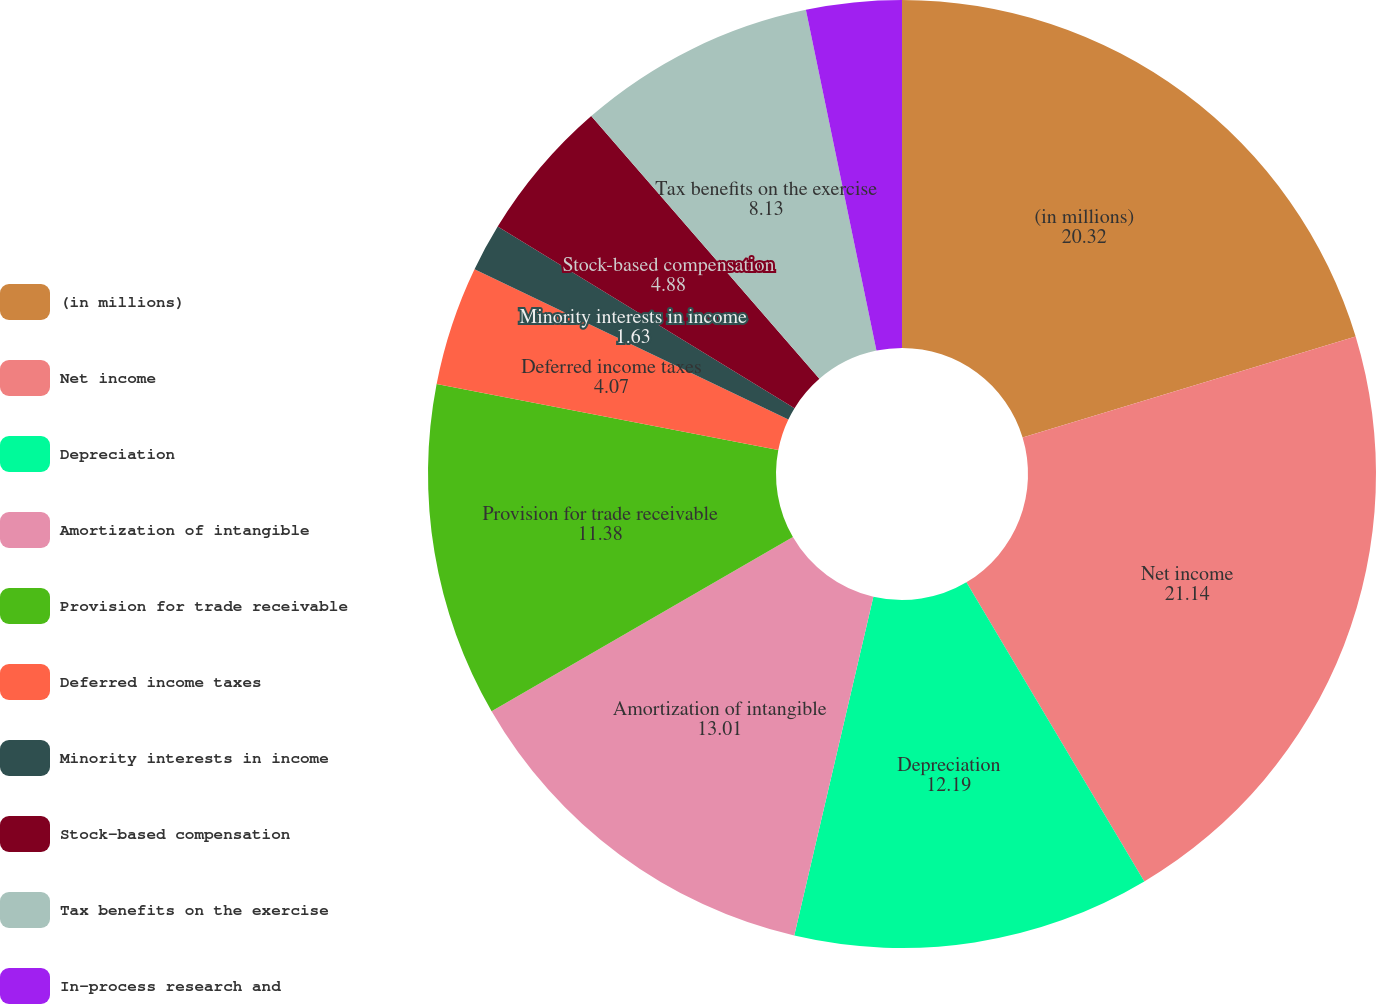Convert chart to OTSL. <chart><loc_0><loc_0><loc_500><loc_500><pie_chart><fcel>(in millions)<fcel>Net income<fcel>Depreciation<fcel>Amortization of intangible<fcel>Provision for trade receivable<fcel>Deferred income taxes<fcel>Minority interests in income<fcel>Stock-based compensation<fcel>Tax benefits on the exercise<fcel>In-process research and<nl><fcel>20.32%<fcel>21.14%<fcel>12.19%<fcel>13.01%<fcel>11.38%<fcel>4.07%<fcel>1.63%<fcel>4.88%<fcel>8.13%<fcel>3.25%<nl></chart> 